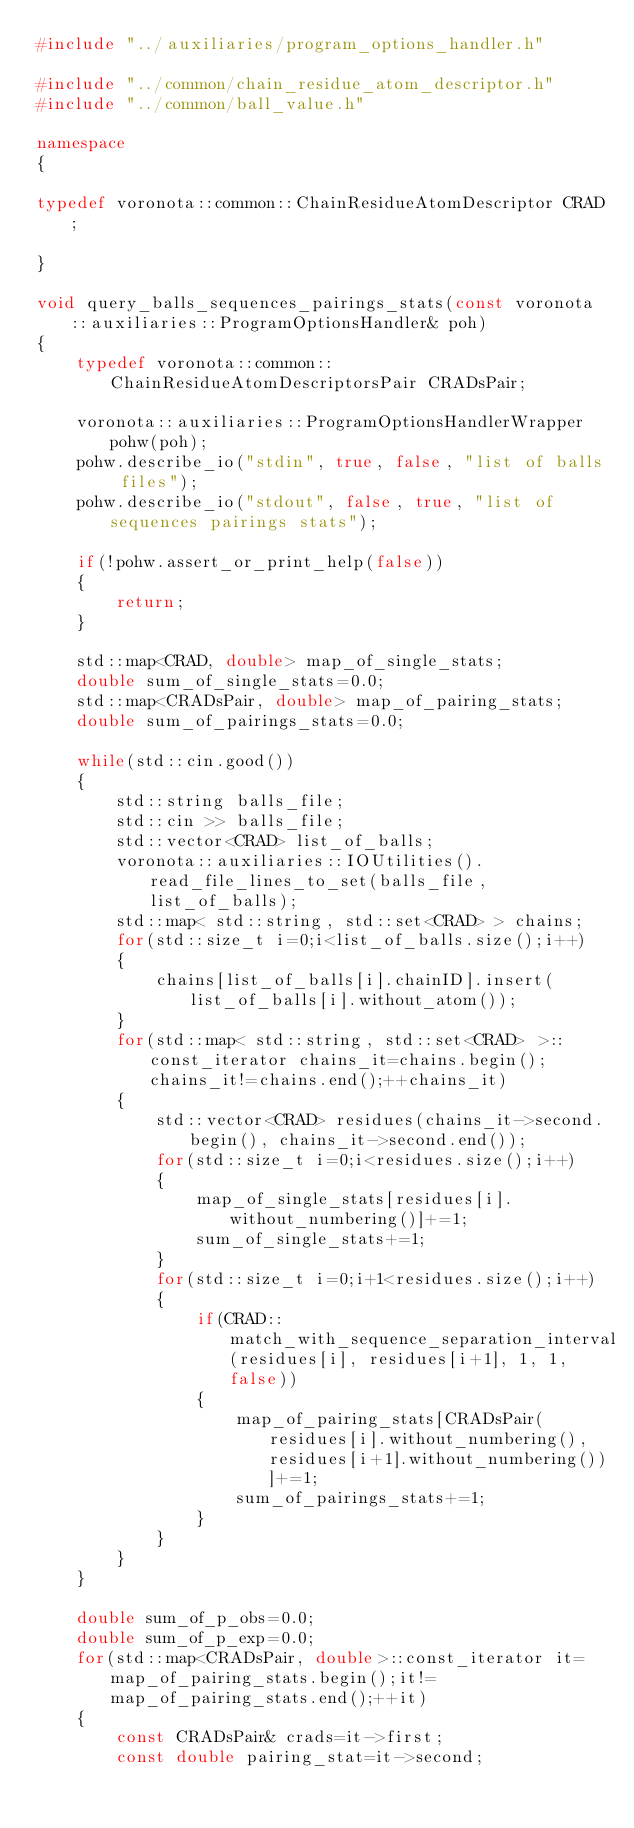<code> <loc_0><loc_0><loc_500><loc_500><_C++_>#include "../auxiliaries/program_options_handler.h"

#include "../common/chain_residue_atom_descriptor.h"
#include "../common/ball_value.h"

namespace
{

typedef voronota::common::ChainResidueAtomDescriptor CRAD;

}

void query_balls_sequences_pairings_stats(const voronota::auxiliaries::ProgramOptionsHandler& poh)
{
	typedef voronota::common::ChainResidueAtomDescriptorsPair CRADsPair;

	voronota::auxiliaries::ProgramOptionsHandlerWrapper pohw(poh);
	pohw.describe_io("stdin", true, false, "list of balls files");
	pohw.describe_io("stdout", false, true, "list of sequences pairings stats");

	if(!pohw.assert_or_print_help(false))
	{
		return;
	}

	std::map<CRAD, double> map_of_single_stats;
	double sum_of_single_stats=0.0;
	std::map<CRADsPair, double> map_of_pairing_stats;
	double sum_of_pairings_stats=0.0;

	while(std::cin.good())
	{
		std::string balls_file;
		std::cin >> balls_file;
		std::vector<CRAD> list_of_balls;
		voronota::auxiliaries::IOUtilities().read_file_lines_to_set(balls_file, list_of_balls);
		std::map< std::string, std::set<CRAD> > chains;
		for(std::size_t i=0;i<list_of_balls.size();i++)
		{
			chains[list_of_balls[i].chainID].insert(list_of_balls[i].without_atom());
		}
		for(std::map< std::string, std::set<CRAD> >::const_iterator chains_it=chains.begin();chains_it!=chains.end();++chains_it)
		{
			std::vector<CRAD> residues(chains_it->second.begin(), chains_it->second.end());
			for(std::size_t i=0;i<residues.size();i++)
			{
				map_of_single_stats[residues[i].without_numbering()]+=1;
				sum_of_single_stats+=1;
			}
			for(std::size_t i=0;i+1<residues.size();i++)
			{
				if(CRAD::match_with_sequence_separation_interval(residues[i], residues[i+1], 1, 1, false))
				{
					map_of_pairing_stats[CRADsPair(residues[i].without_numbering(), residues[i+1].without_numbering())]+=1;
					sum_of_pairings_stats+=1;
				}
			}
		}
	}

	double sum_of_p_obs=0.0;
	double sum_of_p_exp=0.0;
	for(std::map<CRADsPair, double>::const_iterator it=map_of_pairing_stats.begin();it!=map_of_pairing_stats.end();++it)
	{
		const CRADsPair& crads=it->first;
		const double pairing_stat=it->second;</code> 